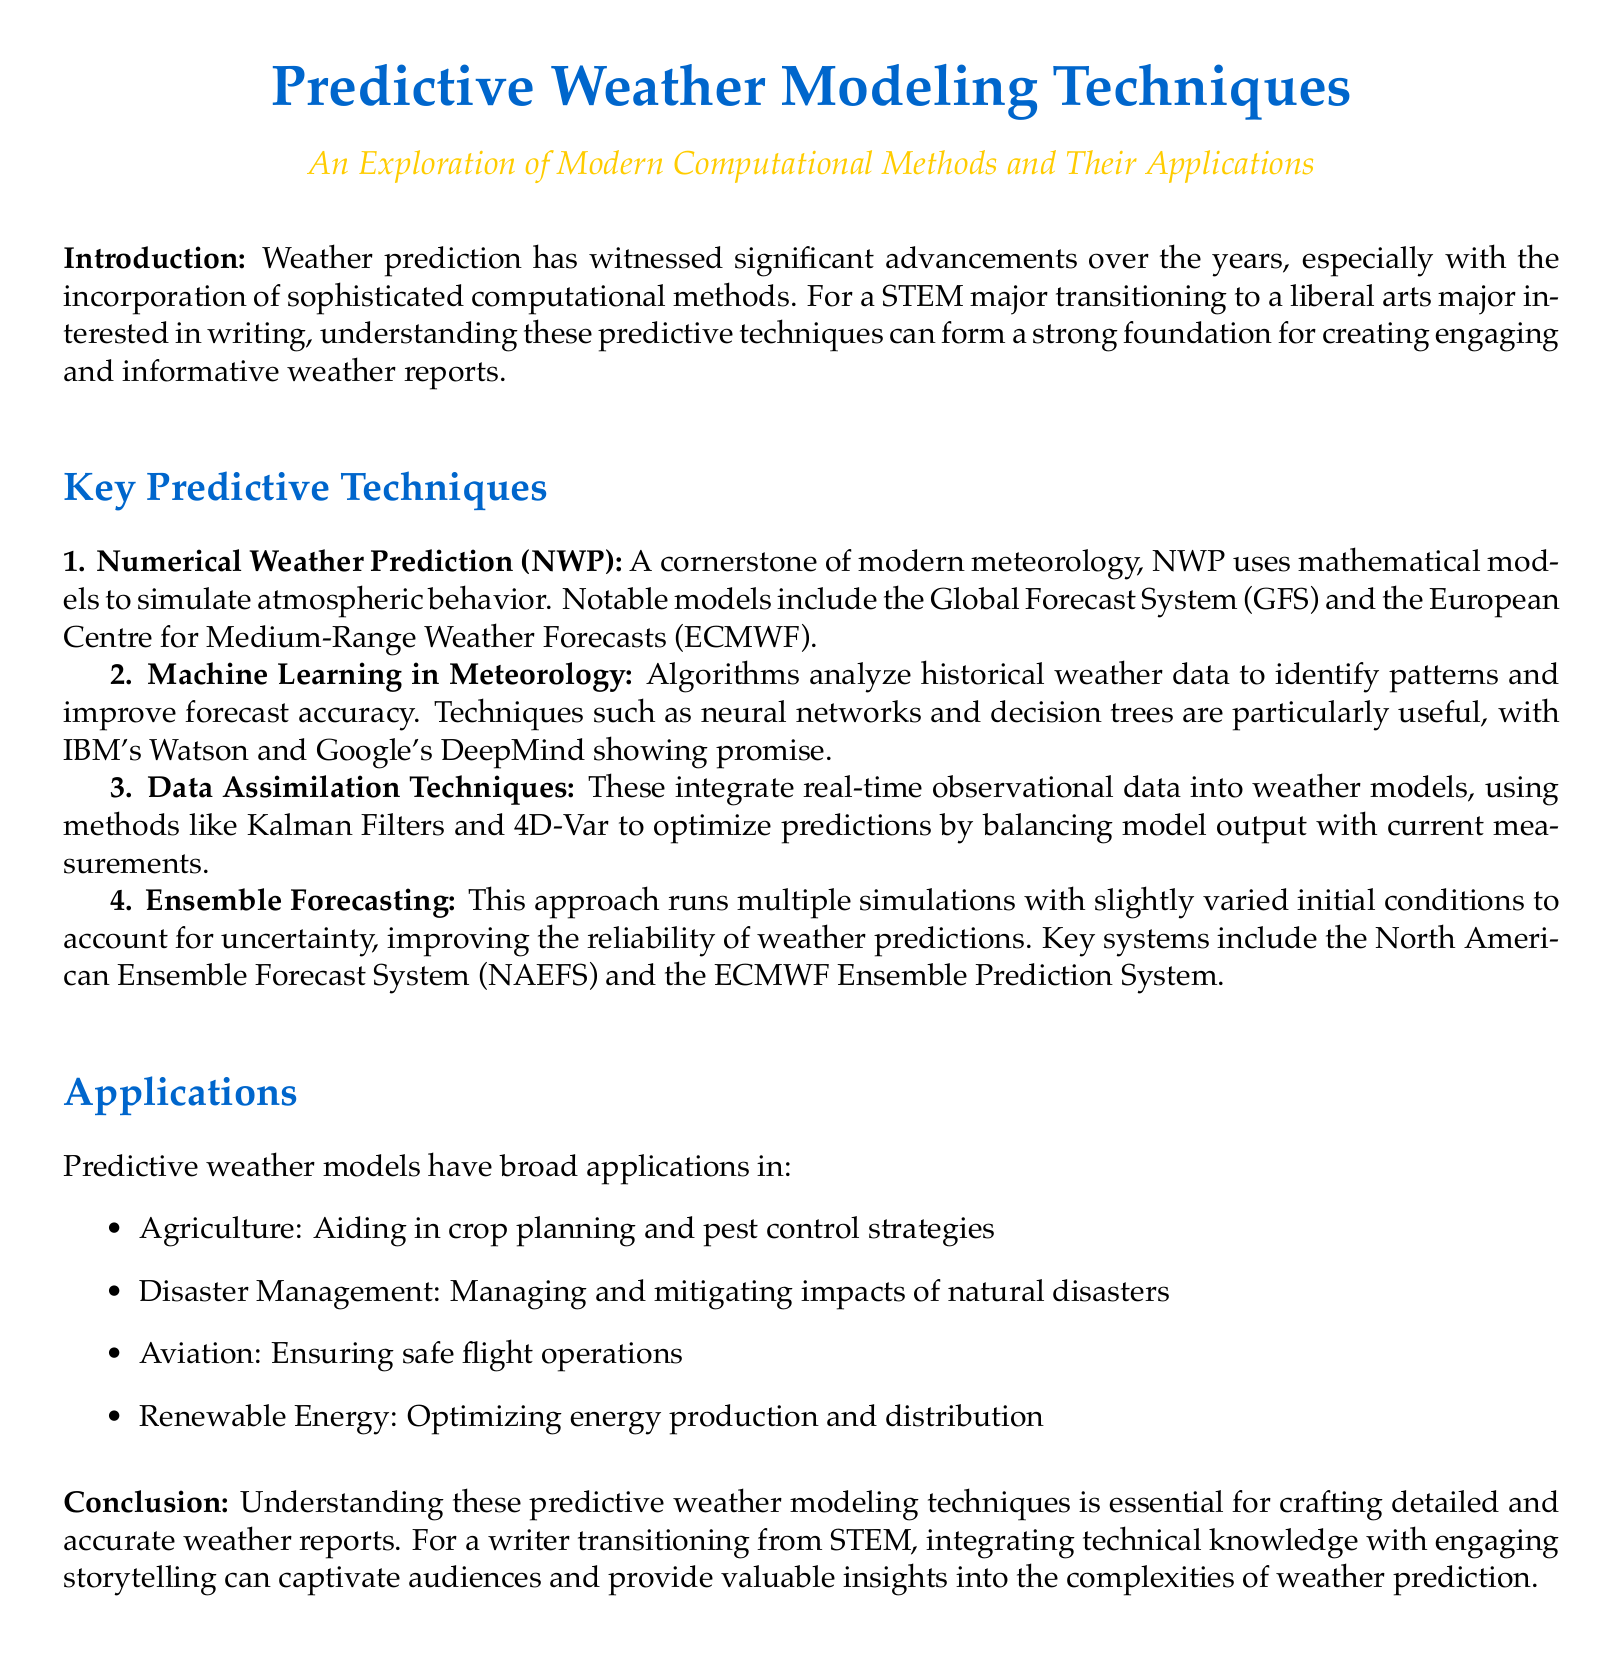What are the key predictive techniques mentioned? The key predictive techniques listed in the document are Numerical Weather Prediction, Machine Learning in Meteorology, Data Assimilation Techniques, and Ensemble Forecasting.
Answer: Numerical Weather Prediction, Machine Learning in Meteorology, Data Assimilation Techniques, Ensemble Forecasting What does NWP stand for? NWP is an abbreviation mentioned in the document that refers to Numerical Weather Prediction, which is a cornerstone of modern meteorology.
Answer: Numerical Weather Prediction Which company developed Watson? The document refers to IBM's Watson as an example of a machine learning application in meteorology.
Answer: IBM What is the role of data assimilation techniques? The document states that data assimilation techniques integrate real-time observational data into weather models, enhancing the accuracy of predictions.
Answer: Integrate real-time observational data Name one application of predictive weather models. The document provides several applications of predictive weather models, and one mentioned is agriculture.
Answer: Agriculture What is the ECMWF? ECMWF is mentioned in the document as a significant model in Numerical Weather Prediction, which stands for the European Centre for Medium-Range Weather Forecasts.
Answer: European Centre for Medium-Range Weather Forecasts Why is ensemble forecasting useful? The document explains that ensemble forecasting improves the reliability of weather predictions by accounting for uncertainty through multiple simulations.
Answer: Accounts for uncertainty What is the purpose of the conclusion in the document? The conclusion summarizes the importance of understanding predictive weather modeling techniques for creating detailed and accurate weather reports.
Answer: Importance for creating detailed reports 